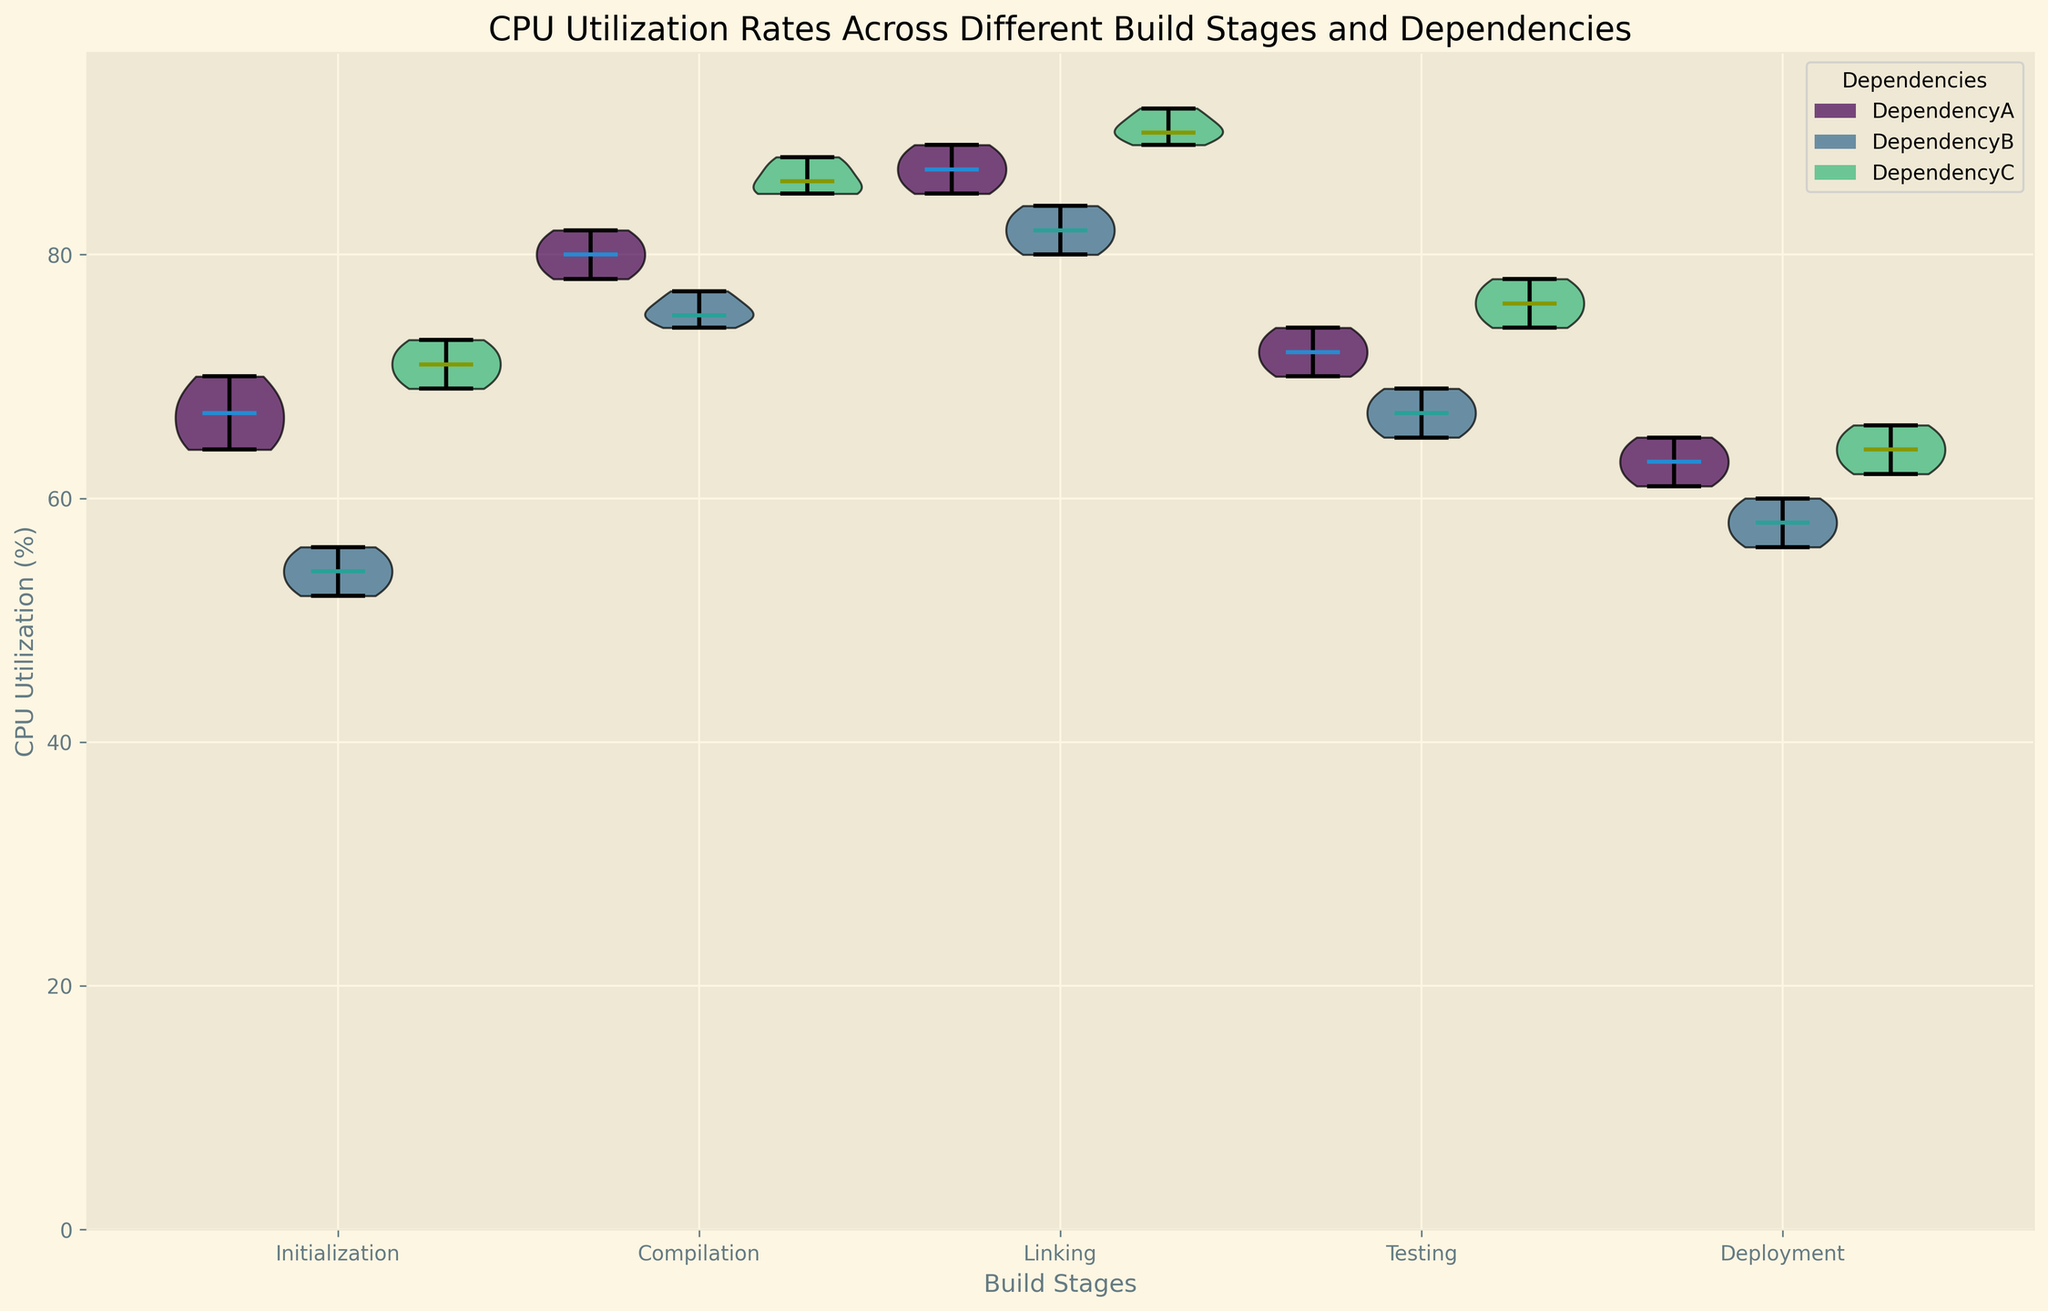Which build stage has the highest median CPU utilization? To determine this, we need to observe the median lines in each violin plot across all build stages. The build stage with the highest median line indicates the highest median CPU utilization.
Answer: Linking Between Dependency A and Dependency B, which has a higher variability in CPU utilization during the Compilation stage? Variability can be inferred from the width and spread of the violin plots. Wider and more spread-out violins indicate higher variability. For the Compilation stage, compare the widths and spreads of the violin plots for Dependency A and B.
Answer: Dependency A What is the difference in the median CPU utilization between the Testing stage and the Deployment stage for Dependency C? We need to locate the median lines for Dependency C in the Testing and Deployment stages and calculate their difference. The Testing median line should be higher than the Deployment median line.
Answer: 12% Which dependency shows the highest CPU utilization during the Linking stage? Identify the highest peak in the violin plots for the Linking stage. The highest point indicates the highest CPU utilization.
Answer: Dependency C How do medians for Dependencies A, B, and C compare in the Initialization stage? Compare the central lines of the violin plots for Dependencies A, B, and C in the Initialization stage. The median lines show the central tendency of CPU utilization.
Answer: Dependency C > Dependency A > Dependency B During the Testing stage, which dependency has the lowest median CPU utilization? Look for the lowest median line among the violin plots for the Testing stage. The lowest median line indicates the lowest median CPU utilization.
Answer: Dependency B Compare the mean CPU utilization for Dependency A during Compilation and Linking stages. Which stage has a higher mean? Although the figure shows median lines, approximate the mean by eyeing the distribution's bulk. For Dependency A, the Linking stage plot is higher overall compared to the Compilation stage.
Answer: Linking Is there a stage where Dependency B consistently uses less CPU than Dependency A? Evaluate each stage by comparing the median lines of Dependencies A and B. Look for stages where the median for Dependency B is always lower.
Answer: Yes, Initialization What is the average CPU utilization for Dependency A and C during the Deployment stage? Calculate the average by summing all CPU utilization values for Dependencies A and C during Deployment and dividing by the number of observations for each dependency.
Answer: (61.0 + 64.0) / 2 = 62.5 Which build stage has the least variability in CPU utilization for Dependency A? Identify the stage where the violin plot for Dependency A is the narrowest and the least spread out, indicating low variability.
Answer: Deployment 